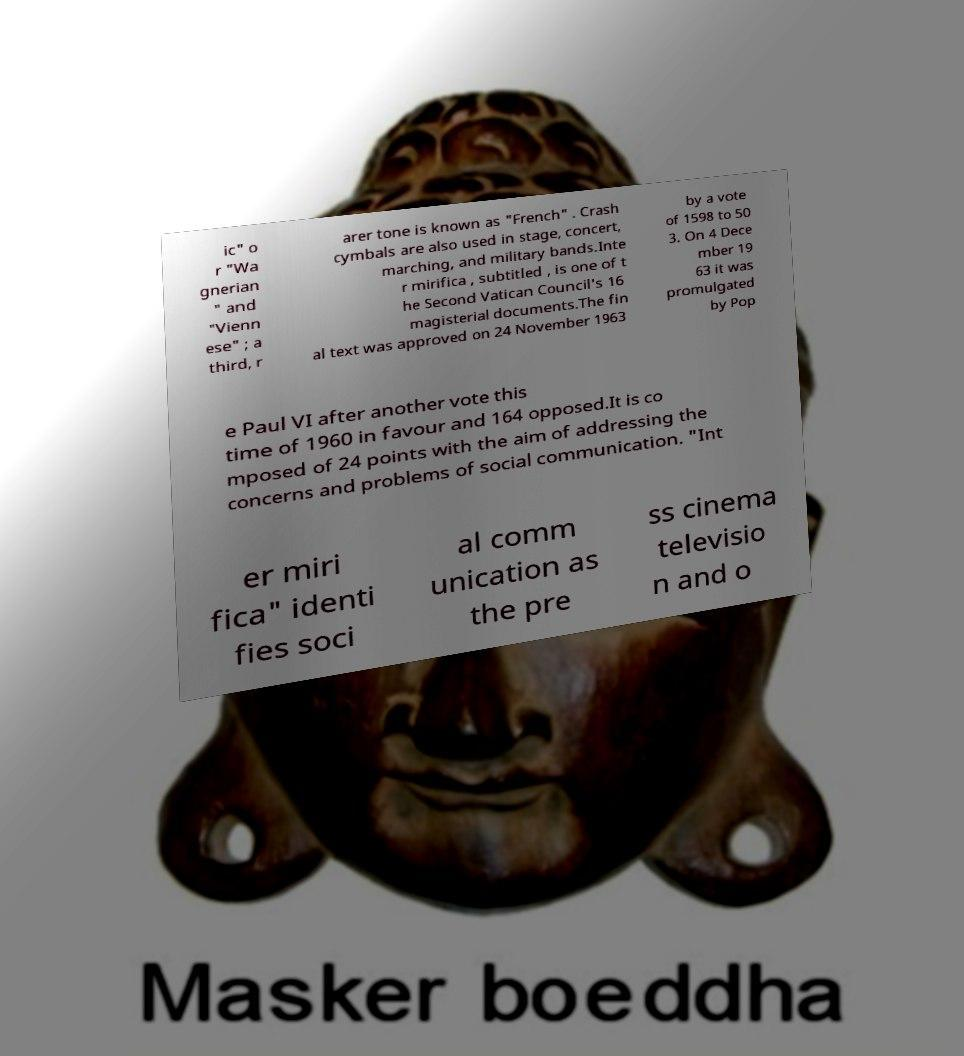Can you read and provide the text displayed in the image?This photo seems to have some interesting text. Can you extract and type it out for me? ic" o r "Wa gnerian " and "Vienn ese" ; a third, r arer tone is known as "French" . Crash cymbals are also used in stage, concert, marching, and military bands.Inte r mirifica , subtitled , is one of t he Second Vatican Council's 16 magisterial documents.The fin al text was approved on 24 November 1963 by a vote of 1598 to 50 3. On 4 Dece mber 19 63 it was promulgated by Pop e Paul VI after another vote this time of 1960 in favour and 164 opposed.It is co mposed of 24 points with the aim of addressing the concerns and problems of social communication. "Int er miri fica" identi fies soci al comm unication as the pre ss cinema televisio n and o 